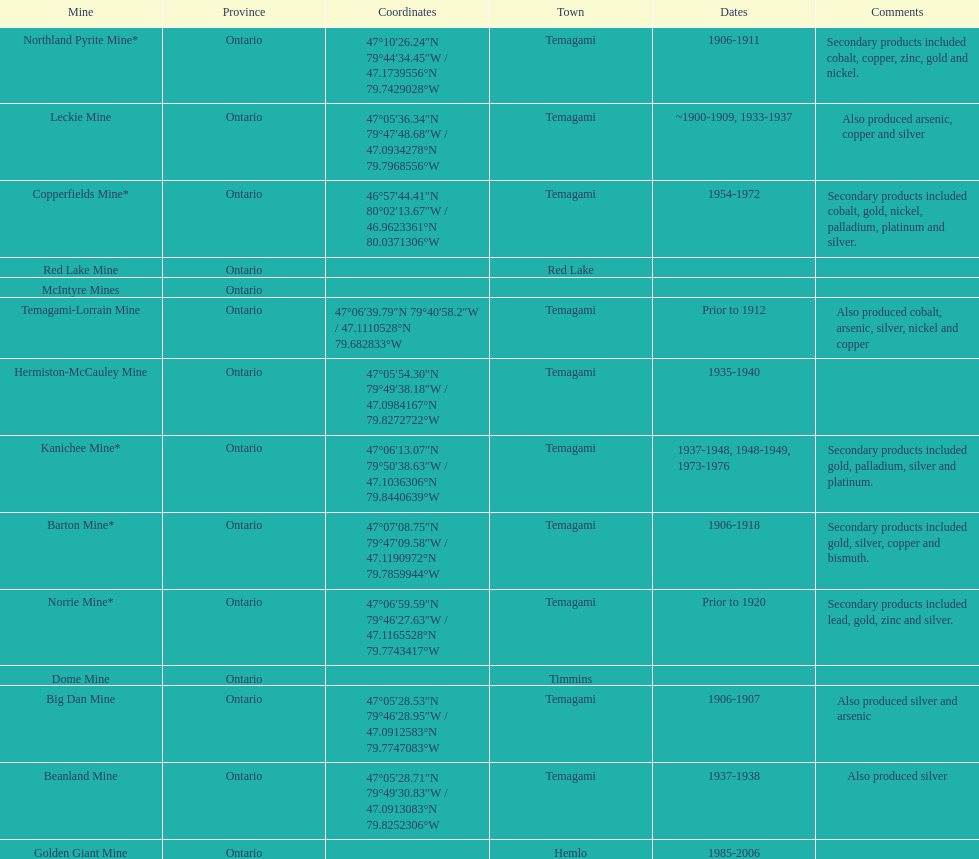In what mine could you find bismuth? Barton Mine. 